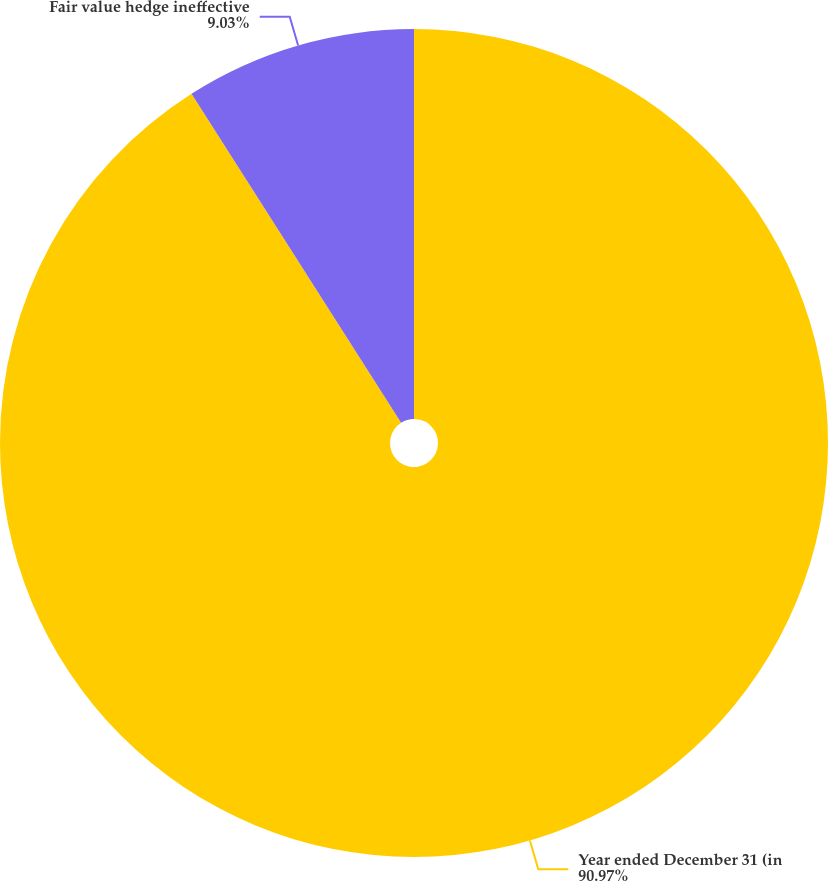<chart> <loc_0><loc_0><loc_500><loc_500><pie_chart><fcel>Year ended December 31 (in<fcel>Fair value hedge ineffective<nl><fcel>90.97%<fcel>9.03%<nl></chart> 